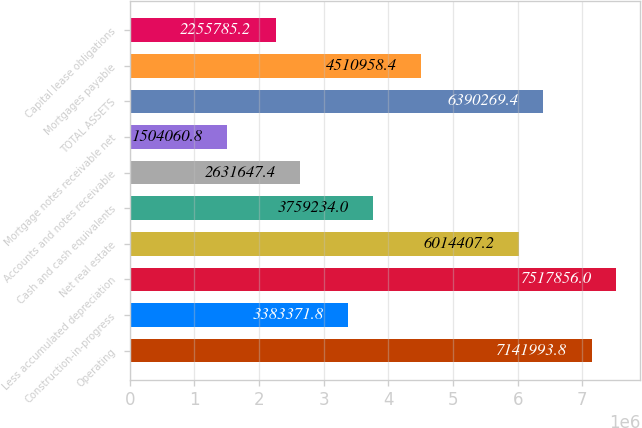Convert chart to OTSL. <chart><loc_0><loc_0><loc_500><loc_500><bar_chart><fcel>Operating<fcel>Construction-in-progress<fcel>Less accumulated depreciation<fcel>Net real estate<fcel>Cash and cash equivalents<fcel>Accounts and notes receivable<fcel>Mortgage notes receivable net<fcel>TOTAL ASSETS<fcel>Mortgages payable<fcel>Capital lease obligations<nl><fcel>7.14199e+06<fcel>3.38337e+06<fcel>7.51786e+06<fcel>6.01441e+06<fcel>3.75923e+06<fcel>2.63165e+06<fcel>1.50406e+06<fcel>6.39027e+06<fcel>4.51096e+06<fcel>2.25579e+06<nl></chart> 